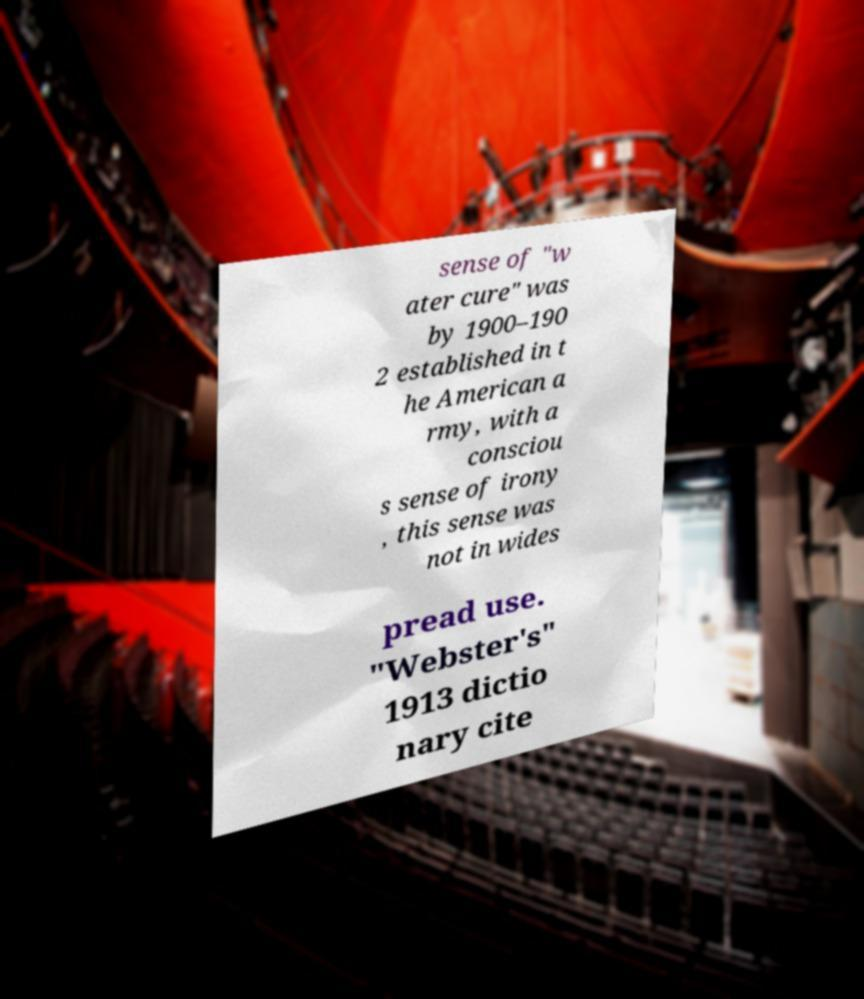For documentation purposes, I need the text within this image transcribed. Could you provide that? sense of "w ater cure" was by 1900–190 2 established in t he American a rmy, with a consciou s sense of irony , this sense was not in wides pread use. "Webster's" 1913 dictio nary cite 